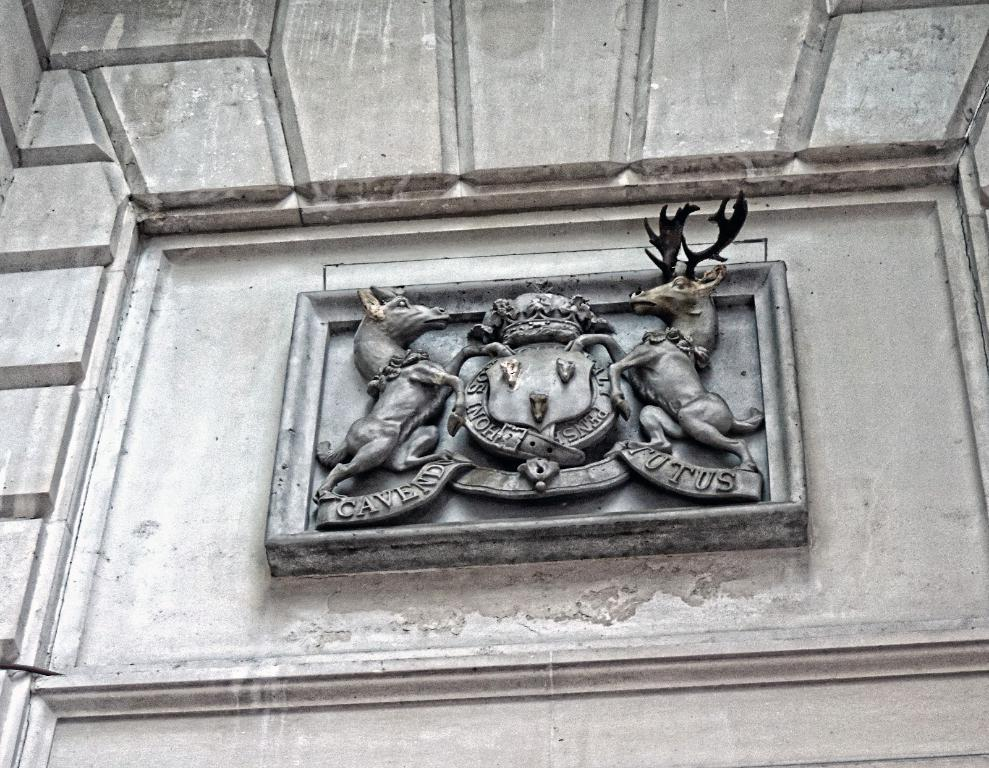What is the main feature of the image? There is a wall in the image. What is on the wall? There is a rock sculpture and text on the wall. How many boys are depicted in the rock sculpture on the wall? There are no boys depicted in the rock sculpture on the wall; it is a sculpture made of rocks. What type of teeth can be seen in the text on the wall? There are no teeth mentioned or depicted in the text on the wall. 